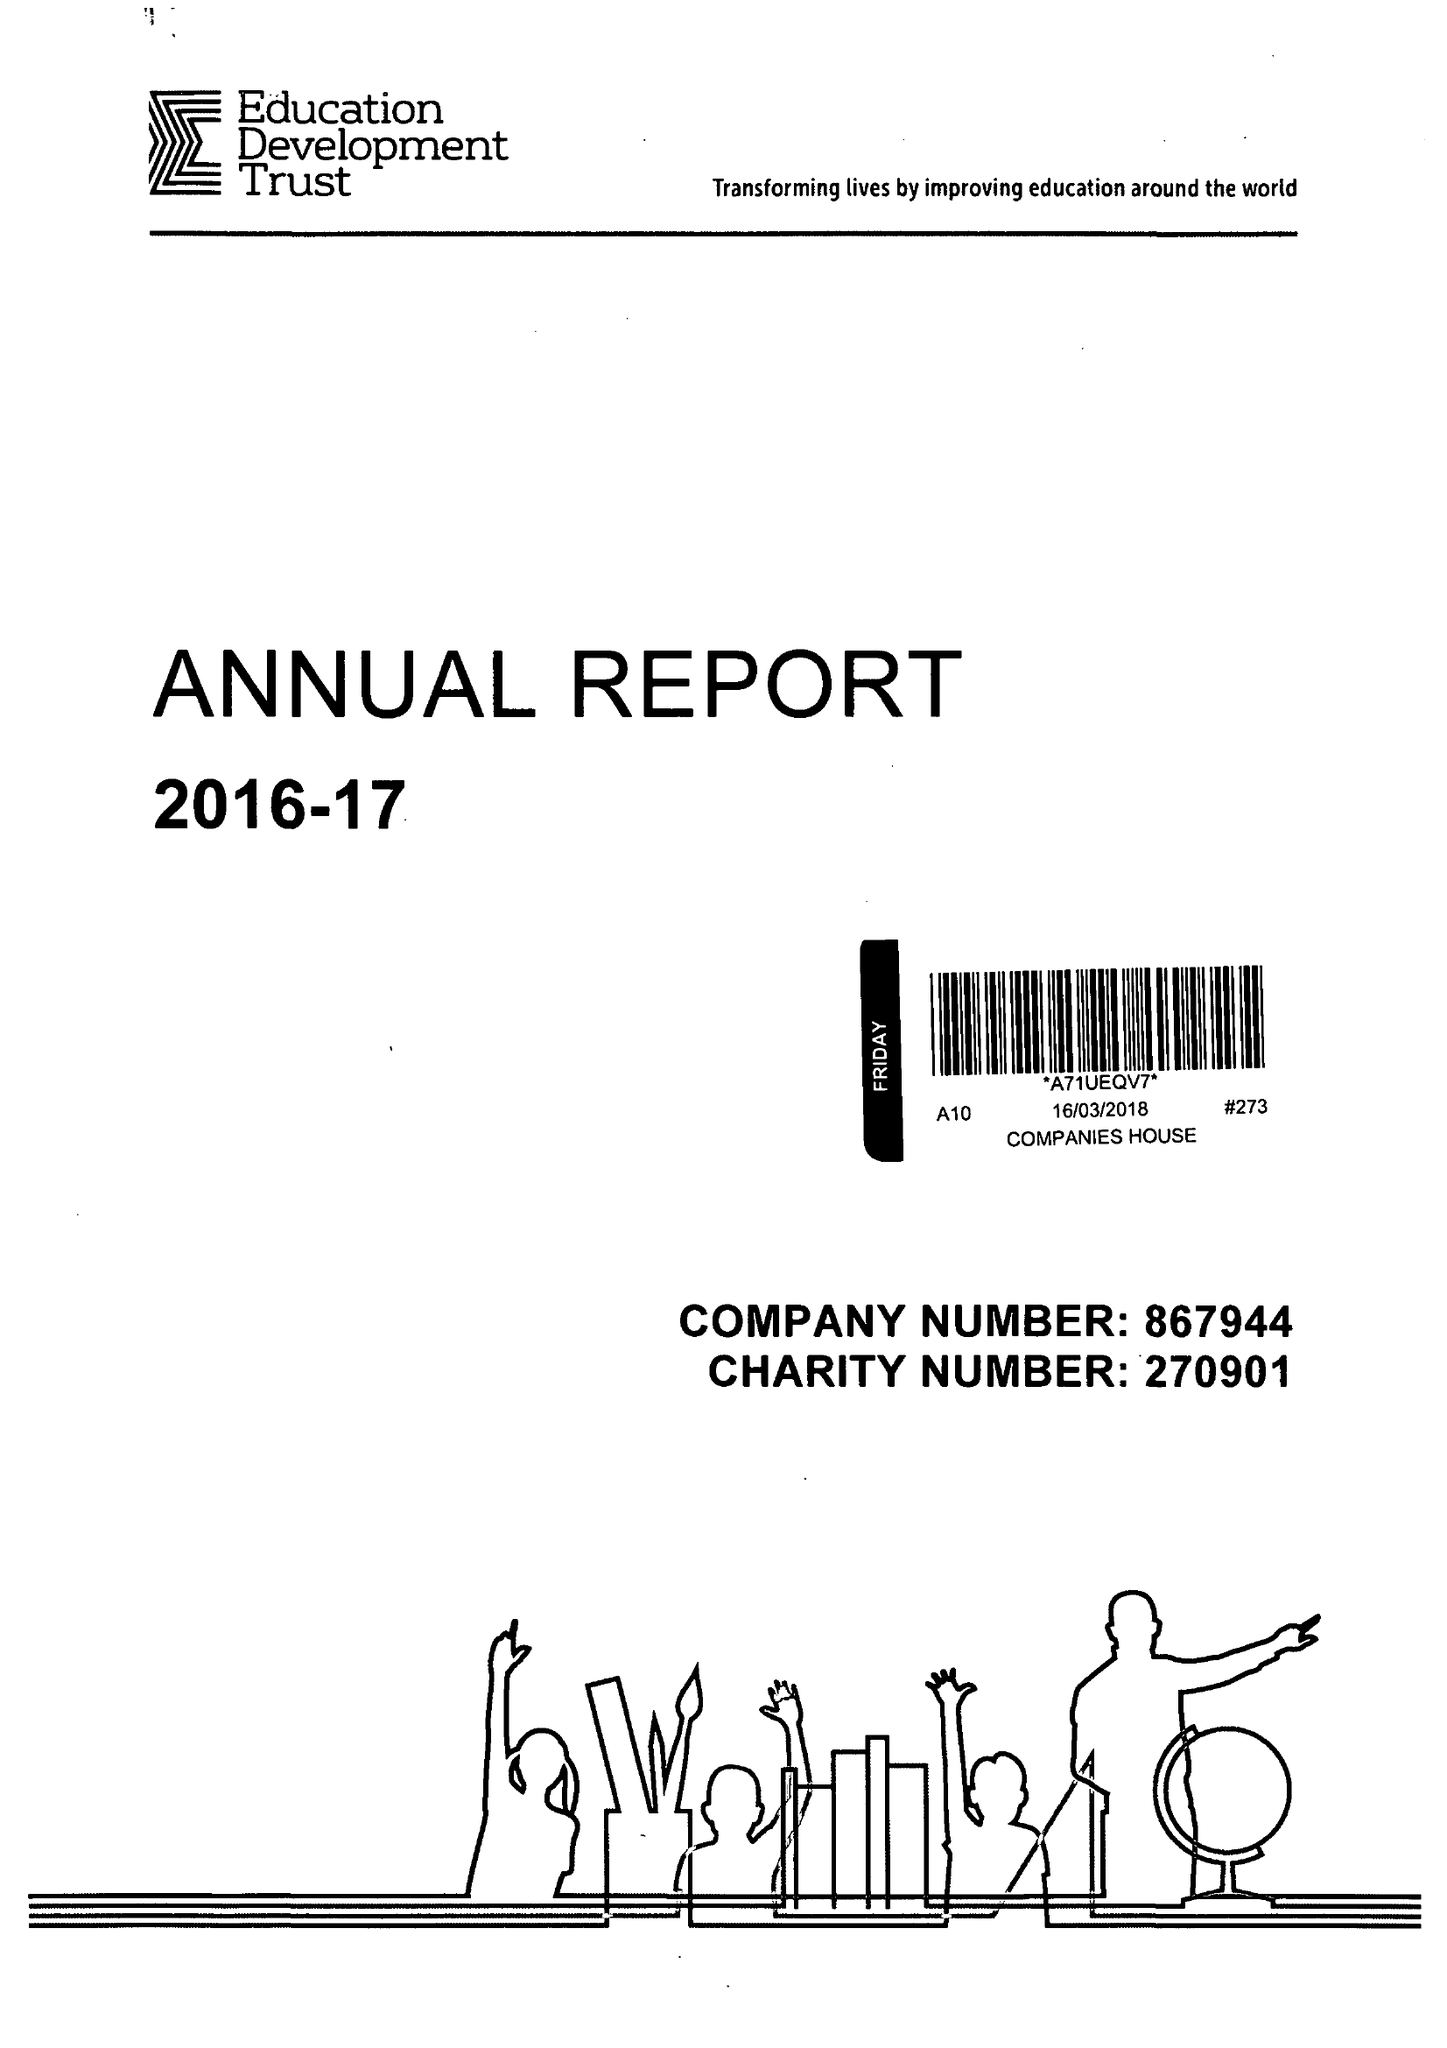What is the value for the spending_annually_in_british_pounds?
Answer the question using a single word or phrase. 66942000.00 